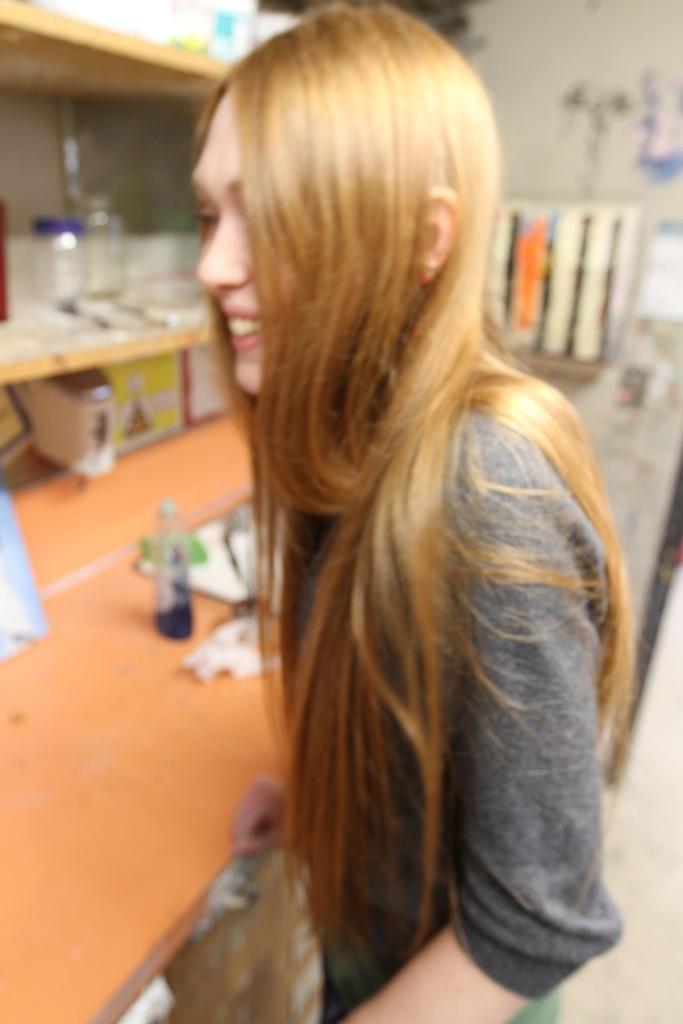Could you give a brief overview of what you see in this image? Here we can see a woman standing and laughing, their table in front of her and a bottle present on it and there is a rack and jars present on them 